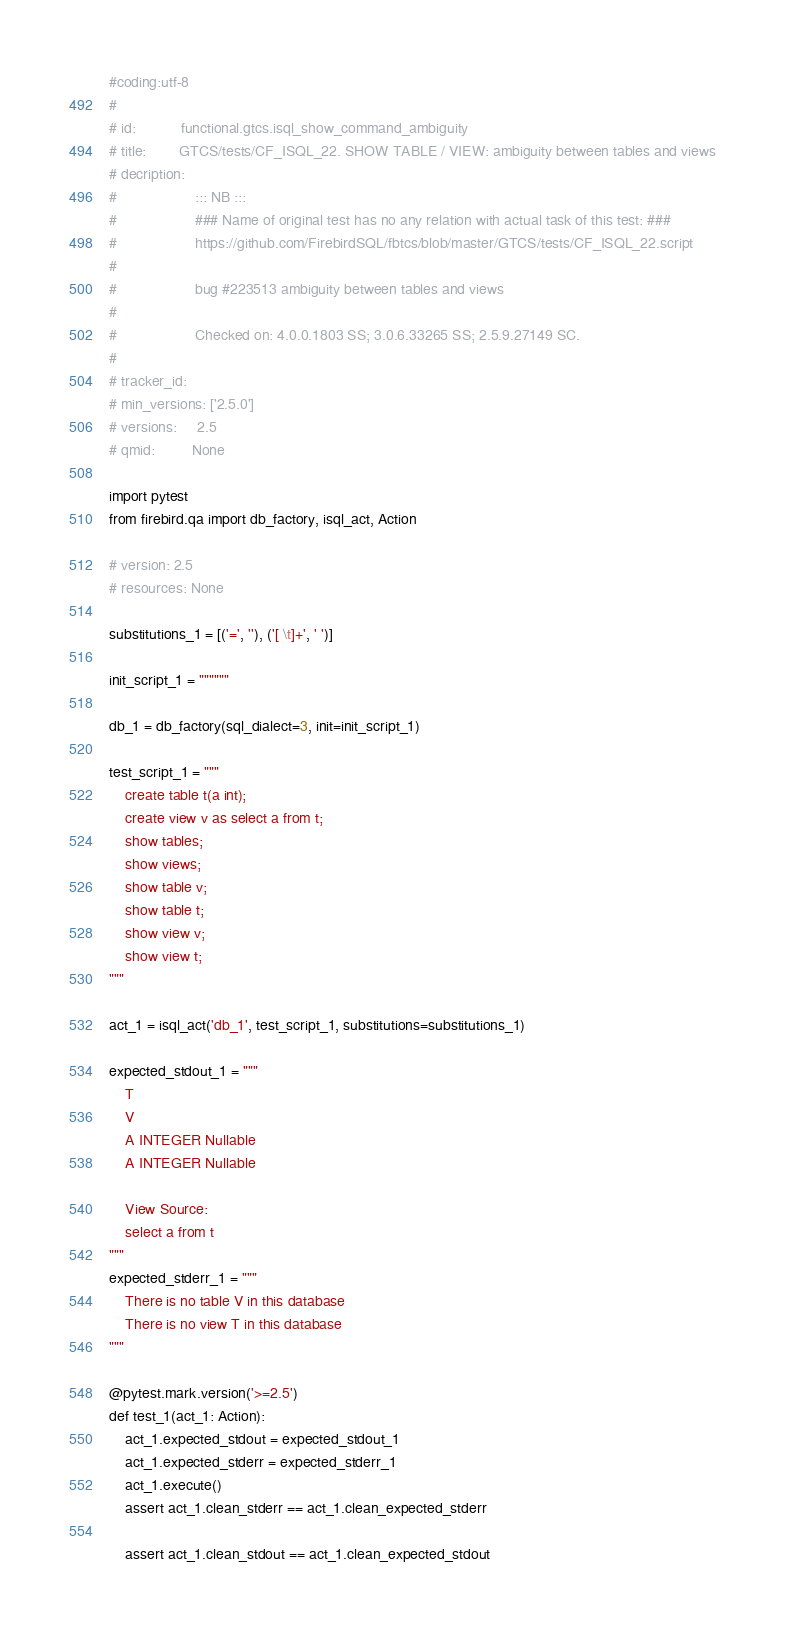Convert code to text. <code><loc_0><loc_0><loc_500><loc_500><_Python_>#coding:utf-8
#
# id:           functional.gtcs.isql_show_command_ambiguity
# title:        GTCS/tests/CF_ISQL_22. SHOW TABLE / VIEW: ambiguity between tables and views
# decription:   
#               	::: NB ::: 
#               	### Name of original test has no any relation with actual task of this test: ###
#                   https://github.com/FirebirdSQL/fbtcs/blob/master/GTCS/tests/CF_ISQL_22.script
#               
#                   bug #223513 ambiguity between tables and views
#               
#                   Checked on: 4.0.0.1803 SS; 3.0.6.33265 SS; 2.5.9.27149 SC.
#                
# tracker_id:   
# min_versions: ['2.5.0']
# versions:     2.5
# qmid:         None

import pytest
from firebird.qa import db_factory, isql_act, Action

# version: 2.5
# resources: None

substitutions_1 = [('=', ''), ('[ \t]+', ' ')]

init_script_1 = """"""

db_1 = db_factory(sql_dialect=3, init=init_script_1)

test_script_1 = """
    create table t(a int);
    create view v as select a from t;
    show tables;
    show views;
    show table v;
    show table t;
    show view v;
    show view t;
"""

act_1 = isql_act('db_1', test_script_1, substitutions=substitutions_1)

expected_stdout_1 = """
    T
    V
    A INTEGER Nullable
    A INTEGER Nullable

    View Source:
    select a from t
"""
expected_stderr_1 = """
    There is no table V in this database
    There is no view T in this database
"""

@pytest.mark.version('>=2.5')
def test_1(act_1: Action):
    act_1.expected_stdout = expected_stdout_1
    act_1.expected_stderr = expected_stderr_1
    act_1.execute()
    assert act_1.clean_stderr == act_1.clean_expected_stderr

    assert act_1.clean_stdout == act_1.clean_expected_stdout

</code> 